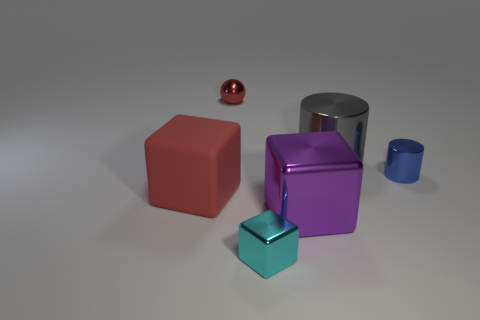What is the shape of the object that is both to the left of the tiny cyan object and behind the small blue shiny thing?
Your answer should be very brief. Sphere. How many small blue shiny objects are there?
Provide a succinct answer. 1. There is a metallic thing that is the same color as the matte object; what shape is it?
Your response must be concise. Sphere. What size is the other matte object that is the same shape as the big purple object?
Your answer should be very brief. Large. There is a large thing on the left side of the small red metallic sphere; is it the same shape as the red metallic object?
Your answer should be compact. No. The big thing left of the small red shiny sphere is what color?
Provide a short and direct response. Red. How many other things are the same size as the sphere?
Your answer should be very brief. 2. Is there any other thing that is the same shape as the gray object?
Provide a short and direct response. Yes. Are there an equal number of big red rubber blocks right of the small cyan cube and yellow metallic spheres?
Make the answer very short. Yes. How many gray things have the same material as the purple cube?
Provide a short and direct response. 1. 